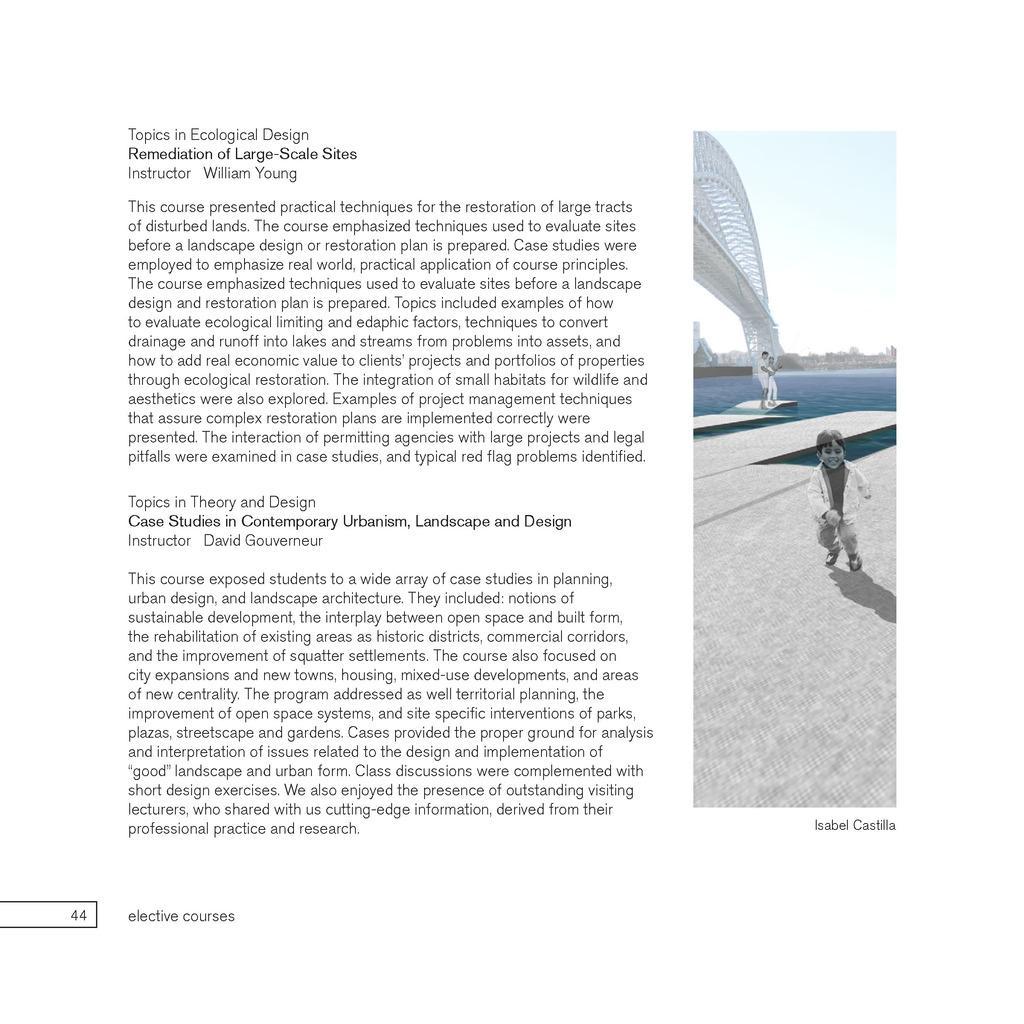Can you describe this image briefly? This is a poster having an image and black color texts. In this image, we can see there is a child running on a platform. In the background, there are two persons, a bridge, water, trees and there are clouds in the sky. 